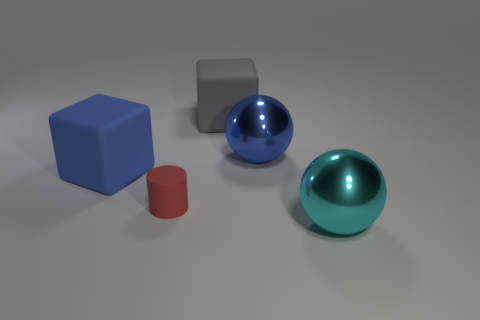Add 2 shiny blocks. How many objects exist? 7 Subtract all cylinders. How many objects are left? 4 Add 5 large matte things. How many large matte things exist? 7 Subtract 0 green cubes. How many objects are left? 5 Subtract all tiny brown metallic cylinders. Subtract all blue matte objects. How many objects are left? 4 Add 5 small red things. How many small red things are left? 6 